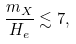<formula> <loc_0><loc_0><loc_500><loc_500>\frac { m _ { X } } { H _ { e } } \lesssim 7 ,</formula> 